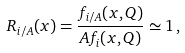Convert formula to latex. <formula><loc_0><loc_0><loc_500><loc_500>R _ { i / A } ( x ) = \frac { f _ { i / A } ( x , Q ) } { A f _ { i } ( x , Q ) } \simeq 1 \, ,</formula> 